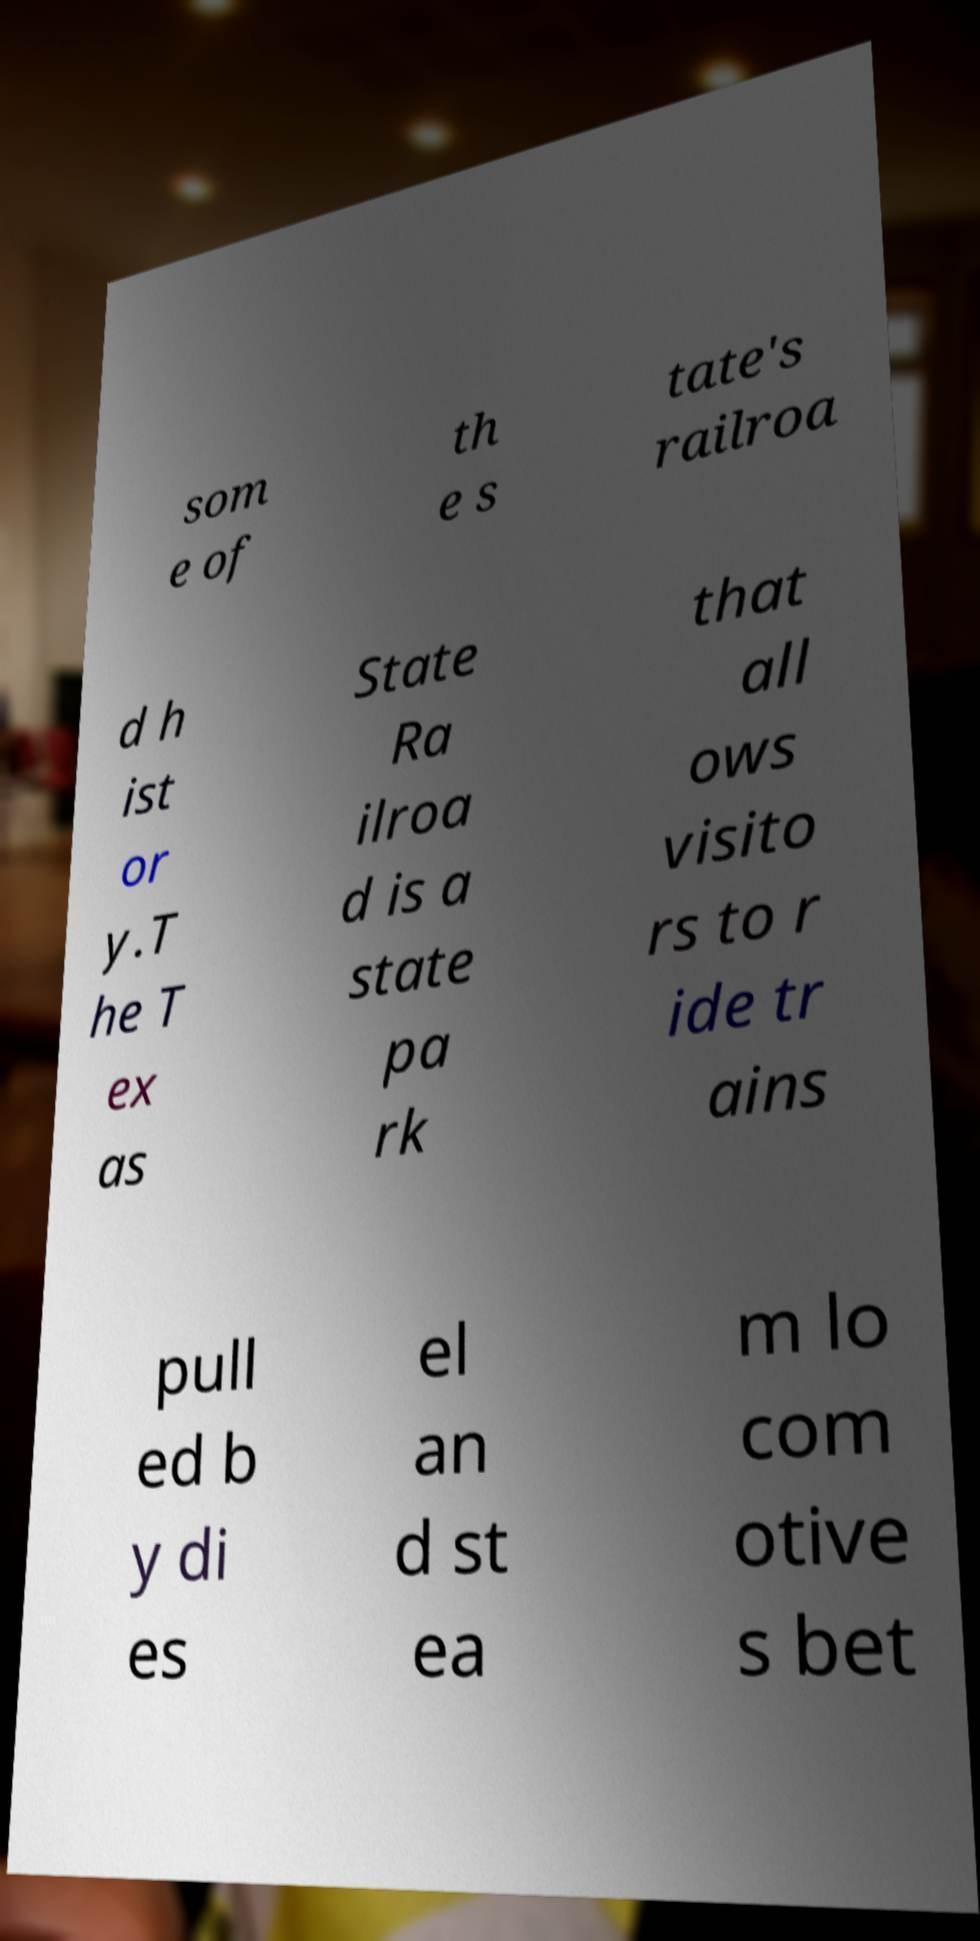Can you accurately transcribe the text from the provided image for me? som e of th e s tate's railroa d h ist or y.T he T ex as State Ra ilroa d is a state pa rk that all ows visito rs to r ide tr ains pull ed b y di es el an d st ea m lo com otive s bet 